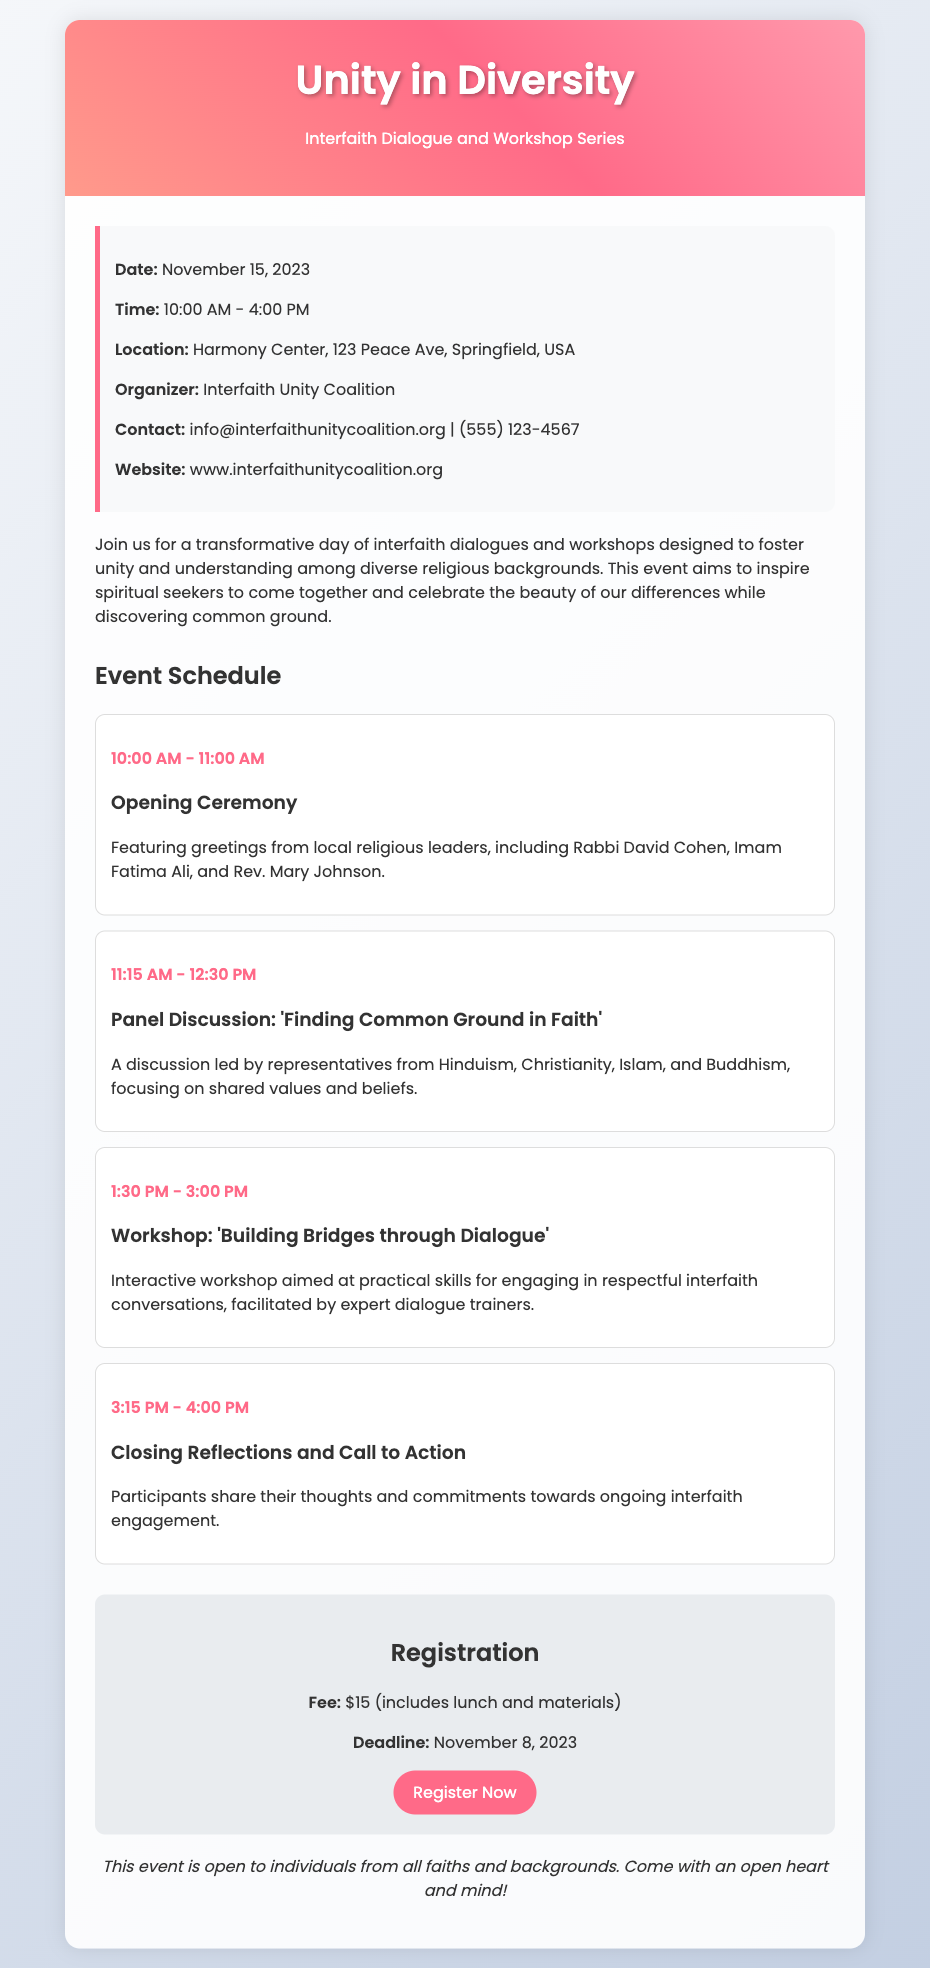What is the date of the event? The date of the event is clearly stated in the event details section of the document.
Answer: November 15, 2023 Where will the event take place? The location of the event is listed in the event details.
Answer: Harmony Center, 123 Peace Ave, Springfield, USA Who is the organizer of the event? The organizer's name is provided in the event details section.
Answer: Interfaith Unity Coalition What is the registration fee? The fee for registration is mentioned in the registration section.
Answer: $15 What is the deadline for registration? The registration deadline is specified in the registration details provided in the document.
Answer: November 8, 2023 Which religious leaders are featured in the opening ceremony? The names of the religious leaders are enumerated in the description of the opening ceremony.
Answer: Rabbi David Cohen, Imam Fatima Ali, Rev. Mary Johnson What is the timing of the panel discussion? The time for the panel discussion is clearly indicated in the event schedule.
Answer: 11:15 AM - 12:30 PM What type of workshop is being offered? The type of workshop is described in the schedule section, highlighting its focus.
Answer: Building Bridges through Dialogue What is the focus of the panel discussion? The topic of the panel discussion is provided in the schedule details.
Answer: Finding Common Ground in Faith 